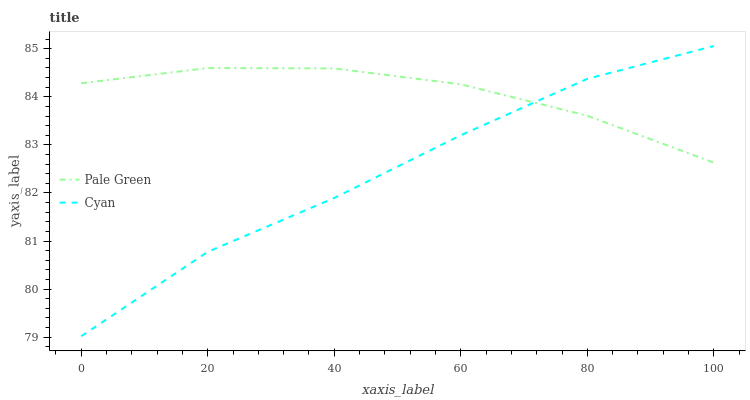Does Cyan have the minimum area under the curve?
Answer yes or no. Yes. Does Pale Green have the maximum area under the curve?
Answer yes or no. Yes. Does Pale Green have the minimum area under the curve?
Answer yes or no. No. Is Pale Green the smoothest?
Answer yes or no. Yes. Is Cyan the roughest?
Answer yes or no. Yes. Is Pale Green the roughest?
Answer yes or no. No. Does Cyan have the lowest value?
Answer yes or no. Yes. Does Pale Green have the lowest value?
Answer yes or no. No. Does Cyan have the highest value?
Answer yes or no. Yes. Does Pale Green have the highest value?
Answer yes or no. No. Does Pale Green intersect Cyan?
Answer yes or no. Yes. Is Pale Green less than Cyan?
Answer yes or no. No. Is Pale Green greater than Cyan?
Answer yes or no. No. 